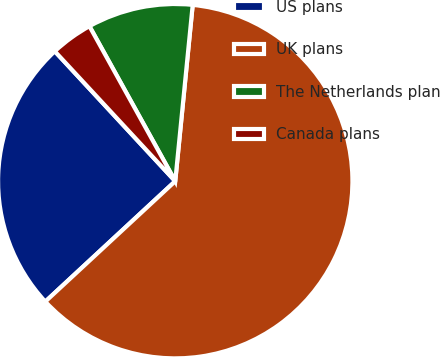<chart> <loc_0><loc_0><loc_500><loc_500><pie_chart><fcel>US plans<fcel>UK plans<fcel>The Netherlands plan<fcel>Canada plans<nl><fcel>25.0%<fcel>61.54%<fcel>9.62%<fcel>3.85%<nl></chart> 